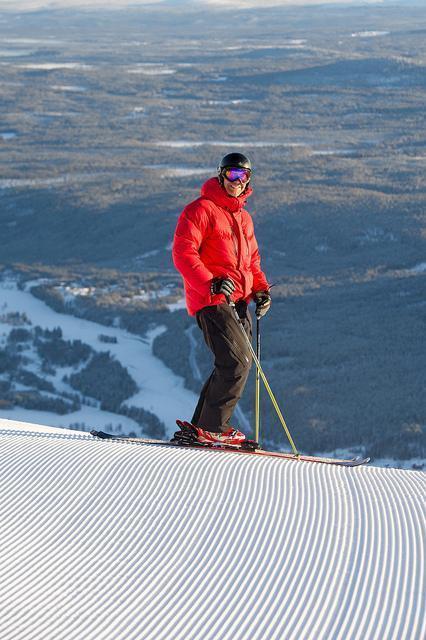How many zebras are laying down?
Give a very brief answer. 0. 